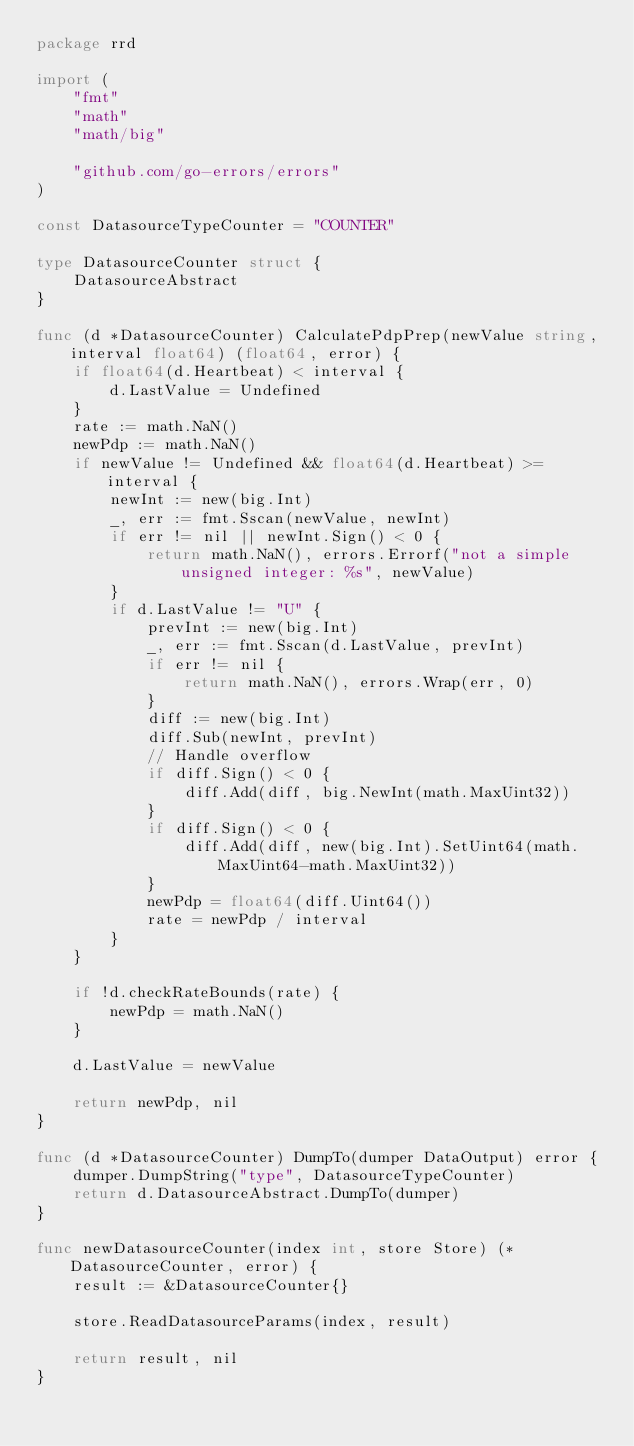Convert code to text. <code><loc_0><loc_0><loc_500><loc_500><_Go_>package rrd

import (
	"fmt"
	"math"
	"math/big"

	"github.com/go-errors/errors"
)

const DatasourceTypeCounter = "COUNTER"

type DatasourceCounter struct {
	DatasourceAbstract
}

func (d *DatasourceCounter) CalculatePdpPrep(newValue string, interval float64) (float64, error) {
	if float64(d.Heartbeat) < interval {
		d.LastValue = Undefined
	}
	rate := math.NaN()
	newPdp := math.NaN()
	if newValue != Undefined && float64(d.Heartbeat) >= interval {
		newInt := new(big.Int)
		_, err := fmt.Sscan(newValue, newInt)
		if err != nil || newInt.Sign() < 0 {
			return math.NaN(), errors.Errorf("not a simple unsigned integer: %s", newValue)
		}
		if d.LastValue != "U" {
			prevInt := new(big.Int)
			_, err := fmt.Sscan(d.LastValue, prevInt)
			if err != nil {
				return math.NaN(), errors.Wrap(err, 0)
			}
			diff := new(big.Int)
			diff.Sub(newInt, prevInt)
			// Handle overflow
			if diff.Sign() < 0 {
				diff.Add(diff, big.NewInt(math.MaxUint32))
			}
			if diff.Sign() < 0 {
				diff.Add(diff, new(big.Int).SetUint64(math.MaxUint64-math.MaxUint32))
			}
			newPdp = float64(diff.Uint64())
			rate = newPdp / interval
		}
	}

	if !d.checkRateBounds(rate) {
		newPdp = math.NaN()
	}

	d.LastValue = newValue

	return newPdp, nil
}

func (d *DatasourceCounter) DumpTo(dumper DataOutput) error {
	dumper.DumpString("type", DatasourceTypeCounter)
	return d.DatasourceAbstract.DumpTo(dumper)
}

func newDatasourceCounter(index int, store Store) (*DatasourceCounter, error) {
	result := &DatasourceCounter{}

	store.ReadDatasourceParams(index, result)

	return result, nil
}
</code> 